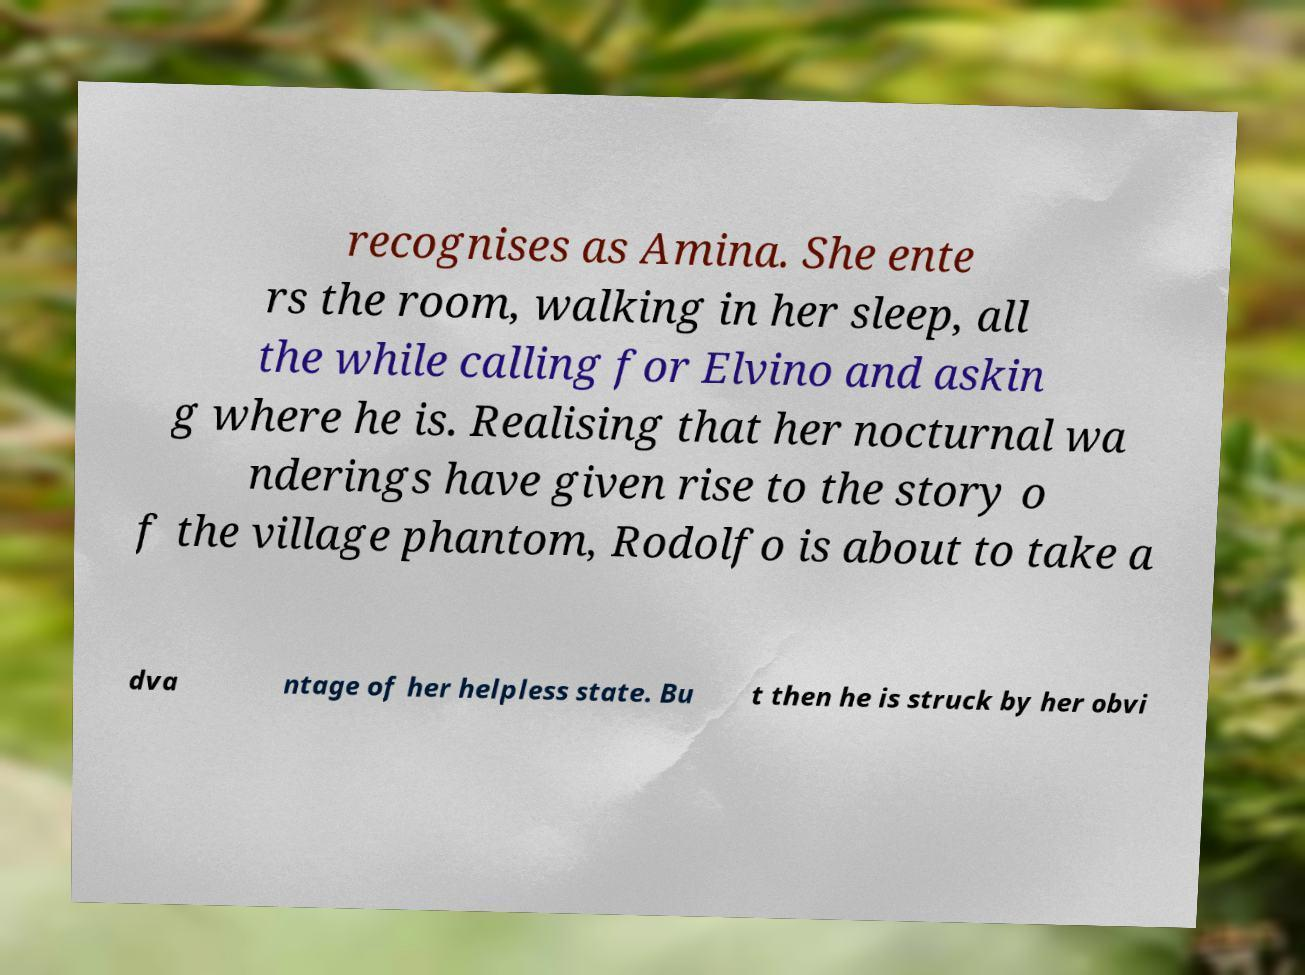Please read and relay the text visible in this image. What does it say? recognises as Amina. She ente rs the room, walking in her sleep, all the while calling for Elvino and askin g where he is. Realising that her nocturnal wa nderings have given rise to the story o f the village phantom, Rodolfo is about to take a dva ntage of her helpless state. Bu t then he is struck by her obvi 